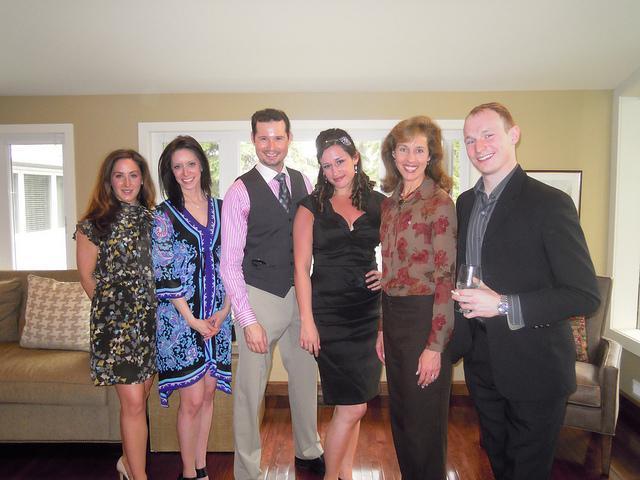How many skateboards are there?
Give a very brief answer. 0. How many people can be seen?
Give a very brief answer. 6. How many black cats are there in the image ?
Give a very brief answer. 0. 